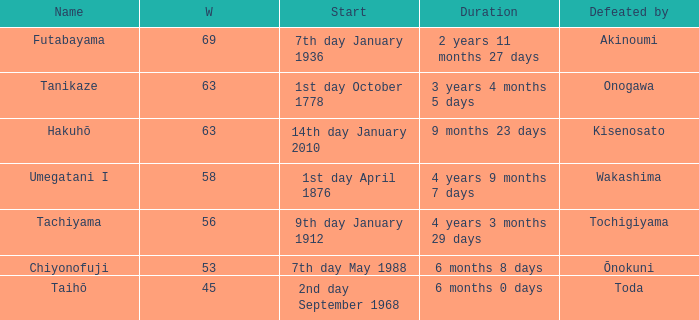How many wins were held before being defeated by toda? 1.0. 